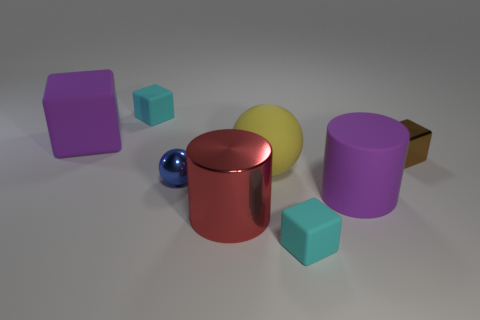What number of yellow rubber balls are there?
Offer a terse response. 1. There is a cylinder that is left of the purple thing right of the purple thing to the left of the red metallic cylinder; what color is it?
Make the answer very short. Red. Is the big rubber cylinder the same color as the big block?
Provide a succinct answer. Yes. What number of purple matte things are in front of the small brown shiny cube and behind the small brown object?
Provide a succinct answer. 0. What number of metal things are either brown things or cylinders?
Your answer should be compact. 2. What material is the brown thing that is in front of the tiny cyan object that is behind the matte ball?
Offer a very short reply. Metal. There is a large rubber thing that is the same color as the large rubber cylinder; what is its shape?
Provide a short and direct response. Cube. There is a yellow rubber object that is the same size as the red shiny object; what is its shape?
Provide a succinct answer. Sphere. Is the number of brown metallic blocks less than the number of cyan objects?
Keep it short and to the point. Yes. Are there any large red cylinders on the left side of the small cyan thing that is in front of the large purple cylinder?
Give a very brief answer. Yes. 